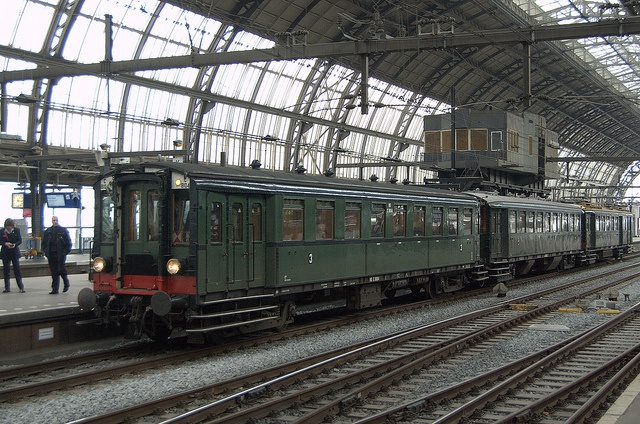Describe the objects in this image and their specific colors. I can see train in white, black, gray, and maroon tones, people in white, black, navy, gray, and darkblue tones, and people in white, black, gray, and darkgray tones in this image. 